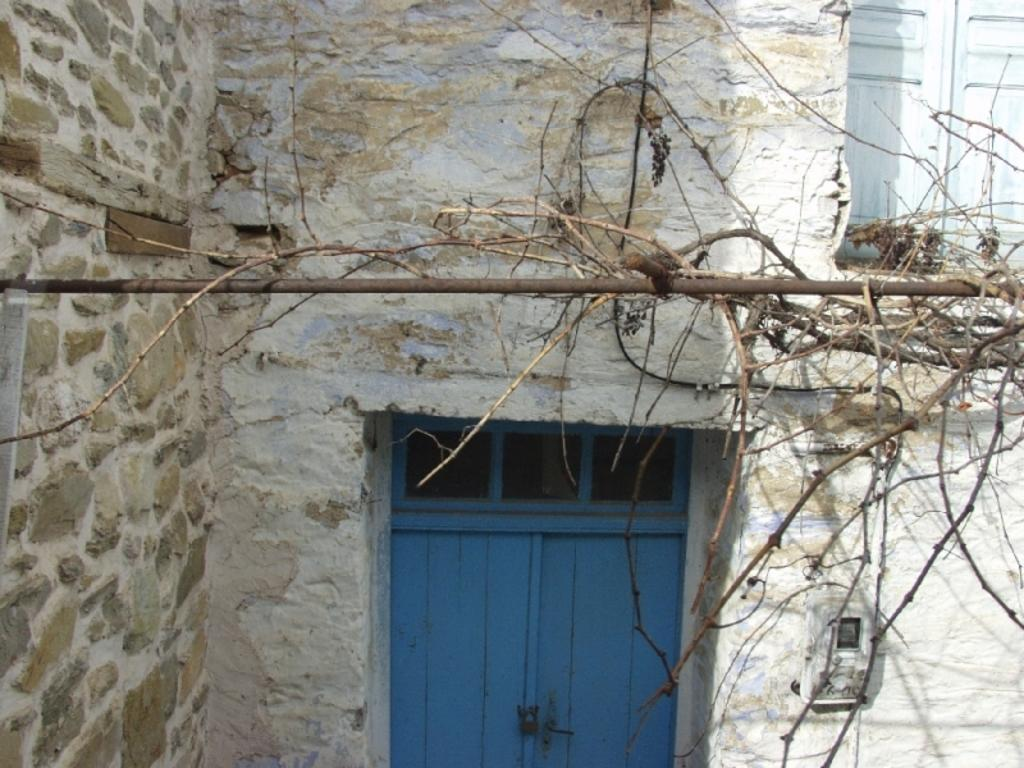What is the color of the building in the image? The building in the image is white. What can be used to enter or exit the building? There are doors in the image. What type of vegetation is present in the image? Creepers are present in the image. What is the tall, thin structure in the image? There is a pole in the image. What device is used to measure and display information in the image? There is a meter board in the image. What type of cork can be seen in the image? There is no cork present in the image. 